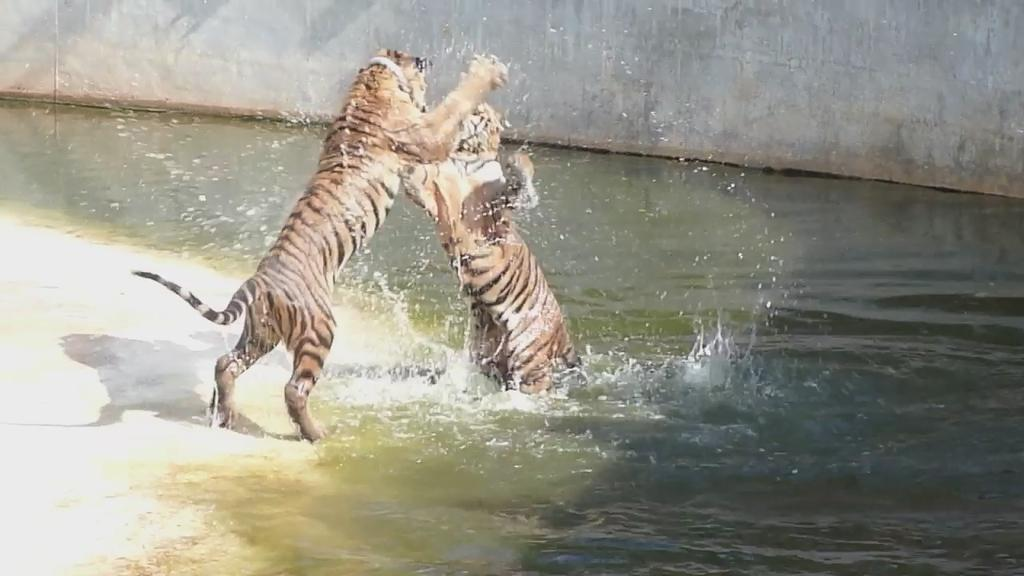How many tigers are in the image? There are two tigers in the image. What are the tigers doing in the image? The tigers appear to be fighting in the water. What can be seen in the background of the image? There is a wall in the background of the image. What type of experience do the bears have in the image? There are no bears present in the image, so it is not possible to determine their experience. 